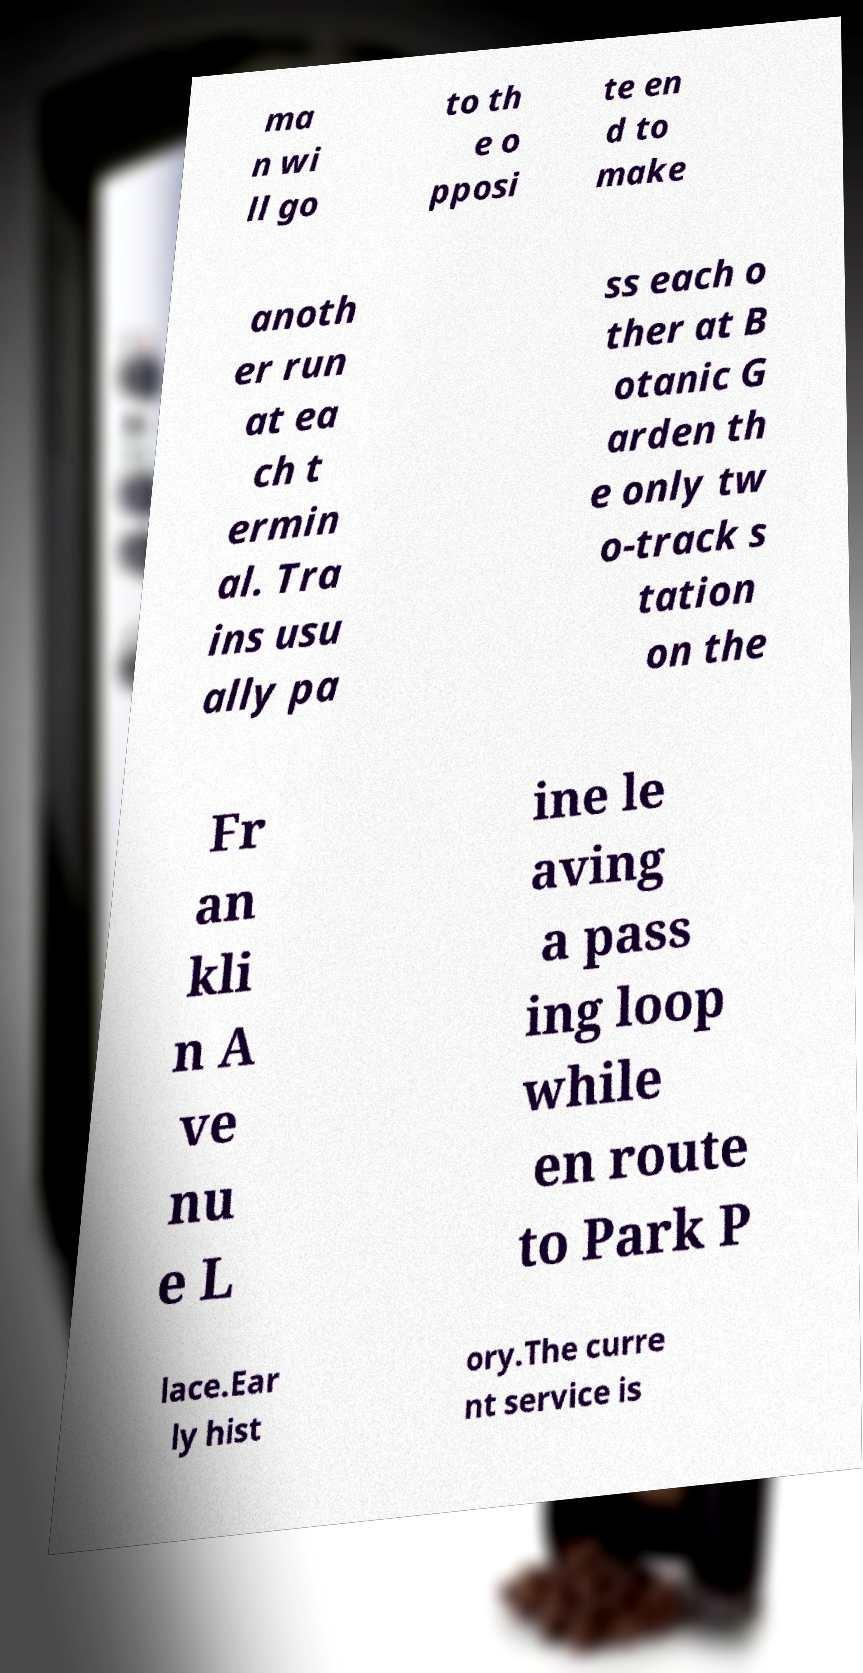I need the written content from this picture converted into text. Can you do that? ma n wi ll go to th e o pposi te en d to make anoth er run at ea ch t ermin al. Tra ins usu ally pa ss each o ther at B otanic G arden th e only tw o-track s tation on the Fr an kli n A ve nu e L ine le aving a pass ing loop while en route to Park P lace.Ear ly hist ory.The curre nt service is 